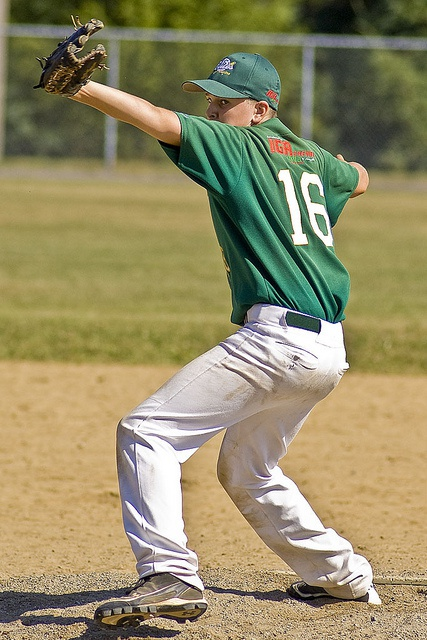Describe the objects in this image and their specific colors. I can see people in tan, white, darkgray, black, and gray tones and baseball glove in tan, black, olive, maroon, and gray tones in this image. 